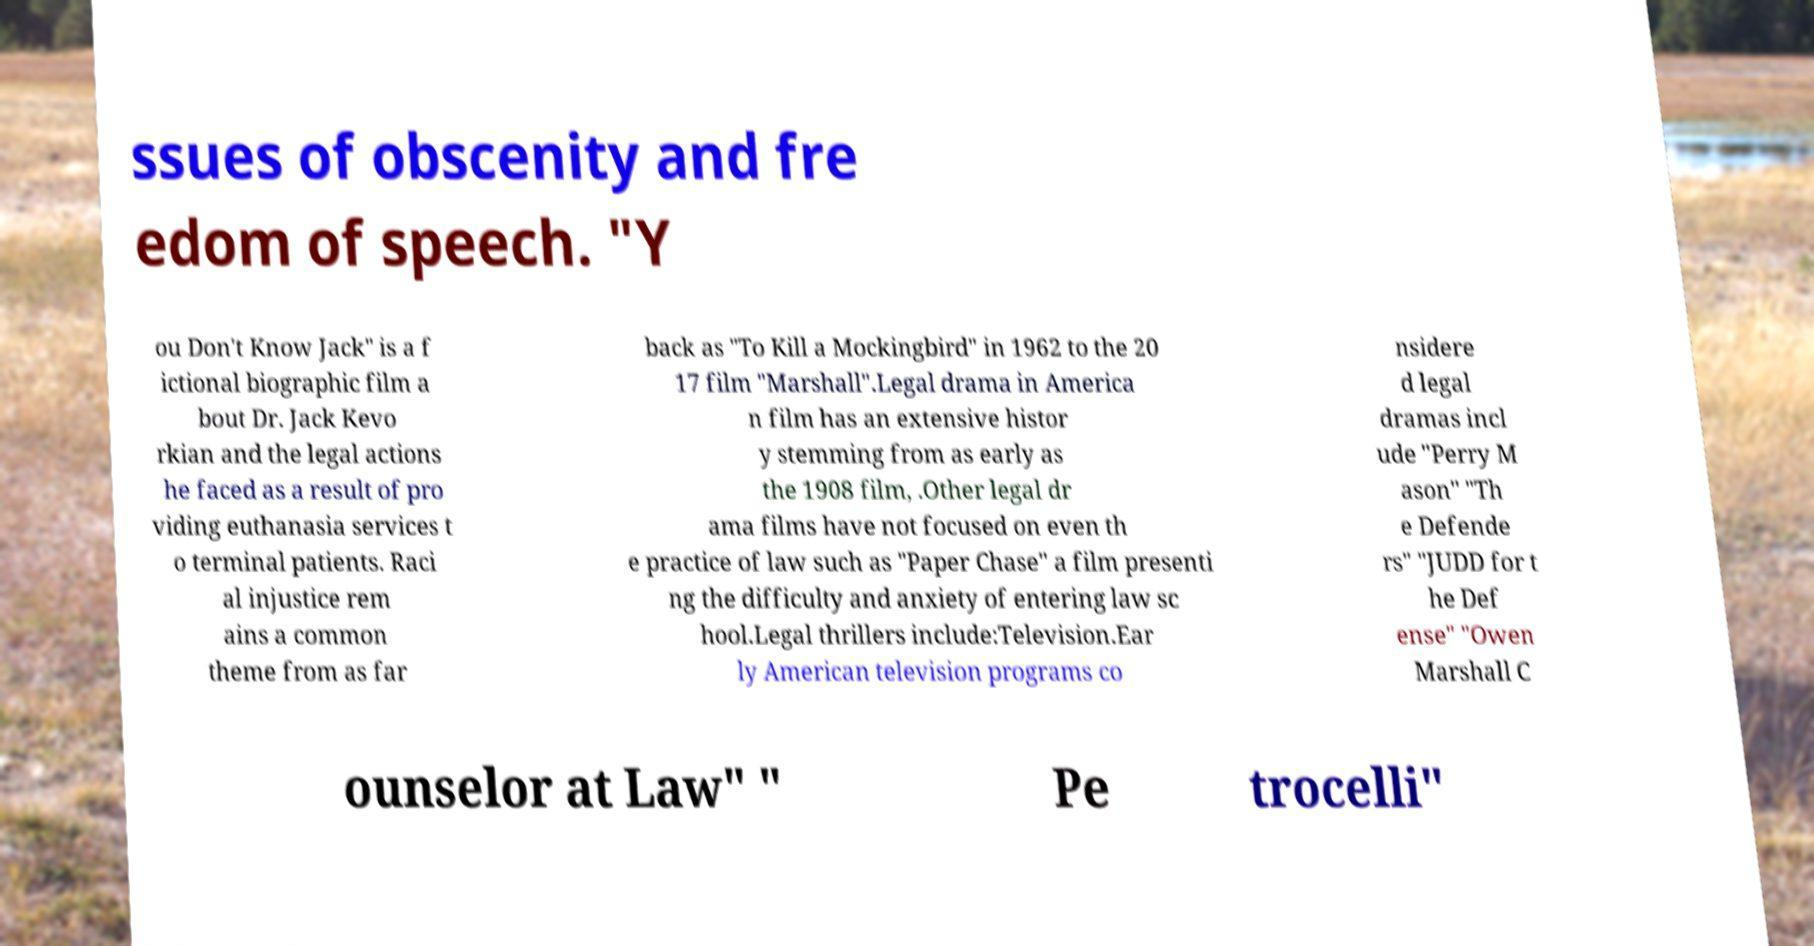Could you extract and type out the text from this image? ssues of obscenity and fre edom of speech. "Y ou Don't Know Jack" is a f ictional biographic film a bout Dr. Jack Kevo rkian and the legal actions he faced as a result of pro viding euthanasia services t o terminal patients. Raci al injustice rem ains a common theme from as far back as "To Kill a Mockingbird" in 1962 to the 20 17 film "Marshall".Legal drama in America n film has an extensive histor y stemming from as early as the 1908 film, .Other legal dr ama films have not focused on even th e practice of law such as "Paper Chase" a film presenti ng the difficulty and anxiety of entering law sc hool.Legal thrillers include:Television.Ear ly American television programs co nsidere d legal dramas incl ude "Perry M ason" "Th e Defende rs" "JUDD for t he Def ense" "Owen Marshall C ounselor at Law" " Pe trocelli" 